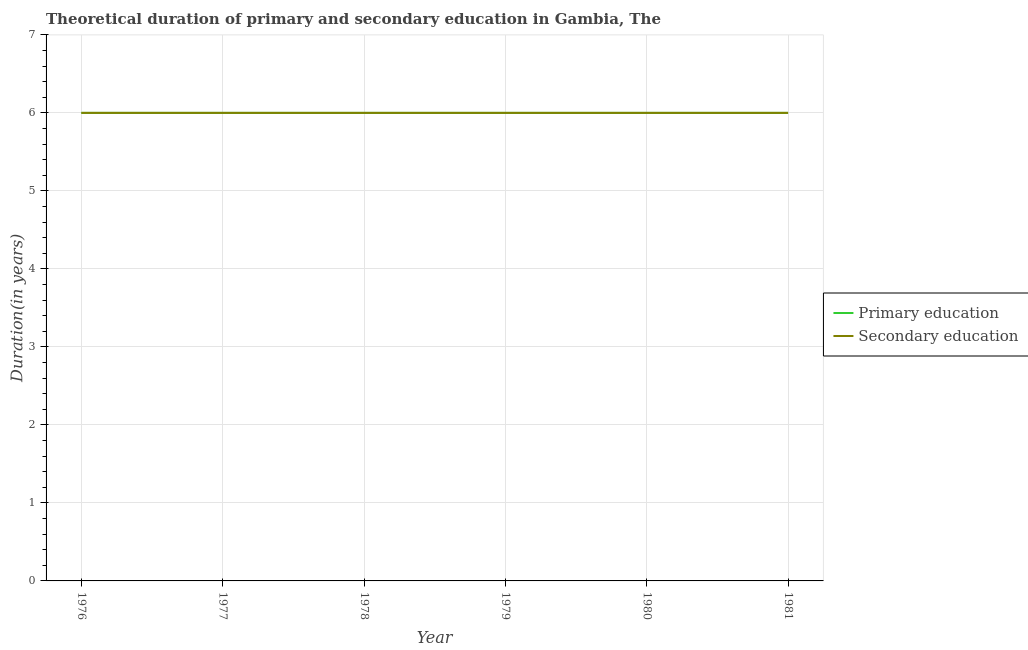What is the duration of primary education in 1980?
Give a very brief answer. 6. Across all years, what is the maximum duration of secondary education?
Ensure brevity in your answer.  6. In which year was the duration of secondary education maximum?
Your answer should be very brief. 1976. In which year was the duration of primary education minimum?
Keep it short and to the point. 1976. What is the total duration of primary education in the graph?
Provide a short and direct response. 36. What is the average duration of primary education per year?
Provide a succinct answer. 6. In the year 1979, what is the difference between the duration of secondary education and duration of primary education?
Your response must be concise. 0. In how many years, is the duration of primary education greater than 1.2 years?
Your response must be concise. 6. What is the ratio of the duration of secondary education in 1977 to that in 1981?
Your response must be concise. 1. Is the duration of secondary education in 1977 less than that in 1978?
Your answer should be very brief. No. Is the difference between the duration of secondary education in 1976 and 1981 greater than the difference between the duration of primary education in 1976 and 1981?
Provide a short and direct response. No. Is the sum of the duration of primary education in 1979 and 1980 greater than the maximum duration of secondary education across all years?
Ensure brevity in your answer.  Yes. How many lines are there?
Make the answer very short. 2. Are the values on the major ticks of Y-axis written in scientific E-notation?
Provide a short and direct response. No. Does the graph contain any zero values?
Offer a terse response. No. Does the graph contain grids?
Provide a short and direct response. Yes. Where does the legend appear in the graph?
Ensure brevity in your answer.  Center right. How are the legend labels stacked?
Your response must be concise. Vertical. What is the title of the graph?
Ensure brevity in your answer.  Theoretical duration of primary and secondary education in Gambia, The. What is the label or title of the Y-axis?
Provide a succinct answer. Duration(in years). What is the Duration(in years) of Primary education in 1976?
Your answer should be very brief. 6. What is the Duration(in years) in Secondary education in 1976?
Ensure brevity in your answer.  6. What is the Duration(in years) in Primary education in 1977?
Make the answer very short. 6. What is the Duration(in years) in Secondary education in 1977?
Give a very brief answer. 6. What is the Duration(in years) of Primary education in 1978?
Make the answer very short. 6. What is the Duration(in years) in Secondary education in 1978?
Offer a very short reply. 6. What is the Duration(in years) in Primary education in 1979?
Offer a terse response. 6. What is the Duration(in years) in Secondary education in 1980?
Keep it short and to the point. 6. What is the Duration(in years) of Secondary education in 1981?
Ensure brevity in your answer.  6. Across all years, what is the maximum Duration(in years) of Secondary education?
Make the answer very short. 6. Across all years, what is the minimum Duration(in years) of Secondary education?
Make the answer very short. 6. What is the total Duration(in years) of Primary education in the graph?
Offer a very short reply. 36. What is the difference between the Duration(in years) in Primary education in 1976 and that in 1977?
Your answer should be very brief. 0. What is the difference between the Duration(in years) of Secondary education in 1976 and that in 1977?
Give a very brief answer. 0. What is the difference between the Duration(in years) of Primary education in 1976 and that in 1979?
Ensure brevity in your answer.  0. What is the difference between the Duration(in years) in Secondary education in 1976 and that in 1979?
Give a very brief answer. 0. What is the difference between the Duration(in years) in Primary education in 1977 and that in 1979?
Make the answer very short. 0. What is the difference between the Duration(in years) in Secondary education in 1977 and that in 1980?
Make the answer very short. 0. What is the difference between the Duration(in years) of Secondary education in 1977 and that in 1981?
Offer a terse response. 0. What is the difference between the Duration(in years) of Primary education in 1978 and that in 1979?
Offer a terse response. 0. What is the difference between the Duration(in years) in Primary education in 1978 and that in 1980?
Offer a terse response. 0. What is the difference between the Duration(in years) in Primary education in 1978 and that in 1981?
Make the answer very short. 0. What is the difference between the Duration(in years) of Secondary education in 1978 and that in 1981?
Give a very brief answer. 0. What is the difference between the Duration(in years) in Secondary education in 1979 and that in 1980?
Give a very brief answer. 0. What is the difference between the Duration(in years) in Secondary education in 1979 and that in 1981?
Provide a short and direct response. 0. What is the difference between the Duration(in years) in Primary education in 1980 and that in 1981?
Ensure brevity in your answer.  0. What is the difference between the Duration(in years) of Primary education in 1976 and the Duration(in years) of Secondary education in 1977?
Give a very brief answer. 0. What is the difference between the Duration(in years) in Primary education in 1976 and the Duration(in years) in Secondary education in 1978?
Your answer should be very brief. 0. What is the difference between the Duration(in years) of Primary education in 1976 and the Duration(in years) of Secondary education in 1980?
Keep it short and to the point. 0. What is the difference between the Duration(in years) of Primary education in 1976 and the Duration(in years) of Secondary education in 1981?
Your response must be concise. 0. What is the difference between the Duration(in years) of Primary education in 1977 and the Duration(in years) of Secondary education in 1980?
Ensure brevity in your answer.  0. What is the difference between the Duration(in years) of Primary education in 1977 and the Duration(in years) of Secondary education in 1981?
Provide a short and direct response. 0. What is the difference between the Duration(in years) of Primary education in 1978 and the Duration(in years) of Secondary education in 1979?
Offer a very short reply. 0. What is the difference between the Duration(in years) in Primary education in 1978 and the Duration(in years) in Secondary education in 1980?
Offer a terse response. 0. What is the difference between the Duration(in years) in Primary education in 1978 and the Duration(in years) in Secondary education in 1981?
Your response must be concise. 0. What is the difference between the Duration(in years) in Primary education in 1980 and the Duration(in years) in Secondary education in 1981?
Offer a terse response. 0. What is the average Duration(in years) in Secondary education per year?
Your answer should be very brief. 6. In the year 1979, what is the difference between the Duration(in years) of Primary education and Duration(in years) of Secondary education?
Provide a succinct answer. 0. In the year 1980, what is the difference between the Duration(in years) in Primary education and Duration(in years) in Secondary education?
Provide a succinct answer. 0. In the year 1981, what is the difference between the Duration(in years) of Primary education and Duration(in years) of Secondary education?
Your answer should be very brief. 0. What is the ratio of the Duration(in years) of Primary education in 1976 to that in 1977?
Offer a terse response. 1. What is the ratio of the Duration(in years) in Primary education in 1976 to that in 1978?
Your answer should be compact. 1. What is the ratio of the Duration(in years) of Primary education in 1976 to that in 1979?
Your answer should be very brief. 1. What is the ratio of the Duration(in years) of Secondary education in 1976 to that in 1979?
Make the answer very short. 1. What is the ratio of the Duration(in years) of Primary education in 1976 to that in 1980?
Your answer should be very brief. 1. What is the ratio of the Duration(in years) in Secondary education in 1976 to that in 1980?
Your answer should be compact. 1. What is the ratio of the Duration(in years) of Primary education in 1976 to that in 1981?
Your response must be concise. 1. What is the ratio of the Duration(in years) of Secondary education in 1976 to that in 1981?
Make the answer very short. 1. What is the ratio of the Duration(in years) in Primary education in 1977 to that in 1978?
Make the answer very short. 1. What is the ratio of the Duration(in years) in Primary education in 1977 to that in 1979?
Your answer should be compact. 1. What is the ratio of the Duration(in years) of Secondary education in 1977 to that in 1979?
Your answer should be compact. 1. What is the ratio of the Duration(in years) in Primary education in 1977 to that in 1980?
Your response must be concise. 1. What is the ratio of the Duration(in years) in Secondary education in 1977 to that in 1981?
Give a very brief answer. 1. What is the ratio of the Duration(in years) of Primary education in 1978 to that in 1979?
Your answer should be compact. 1. What is the ratio of the Duration(in years) of Primary education in 1978 to that in 1980?
Provide a short and direct response. 1. What is the ratio of the Duration(in years) of Primary education in 1978 to that in 1981?
Offer a very short reply. 1. What is the ratio of the Duration(in years) in Primary education in 1979 to that in 1980?
Make the answer very short. 1. What is the ratio of the Duration(in years) in Primary education in 1979 to that in 1981?
Offer a very short reply. 1. What is the ratio of the Duration(in years) in Secondary education in 1979 to that in 1981?
Your answer should be very brief. 1. What is the ratio of the Duration(in years) of Primary education in 1980 to that in 1981?
Make the answer very short. 1. What is the difference between the highest and the lowest Duration(in years) in Secondary education?
Keep it short and to the point. 0. 